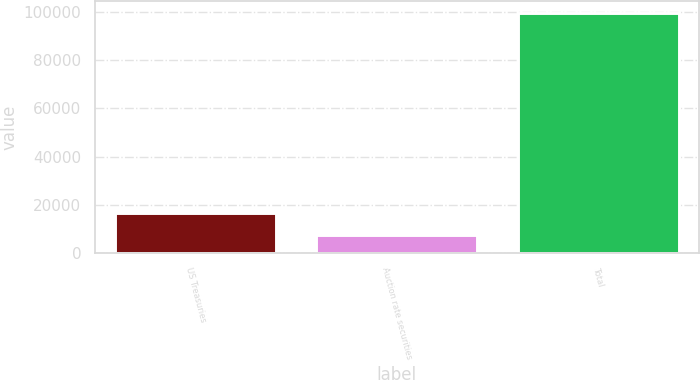Convert chart. <chart><loc_0><loc_0><loc_500><loc_500><bar_chart><fcel>US Treasuries<fcel>Auction rate securities<fcel>Total<nl><fcel>16838.9<fcel>7674<fcel>99323<nl></chart> 